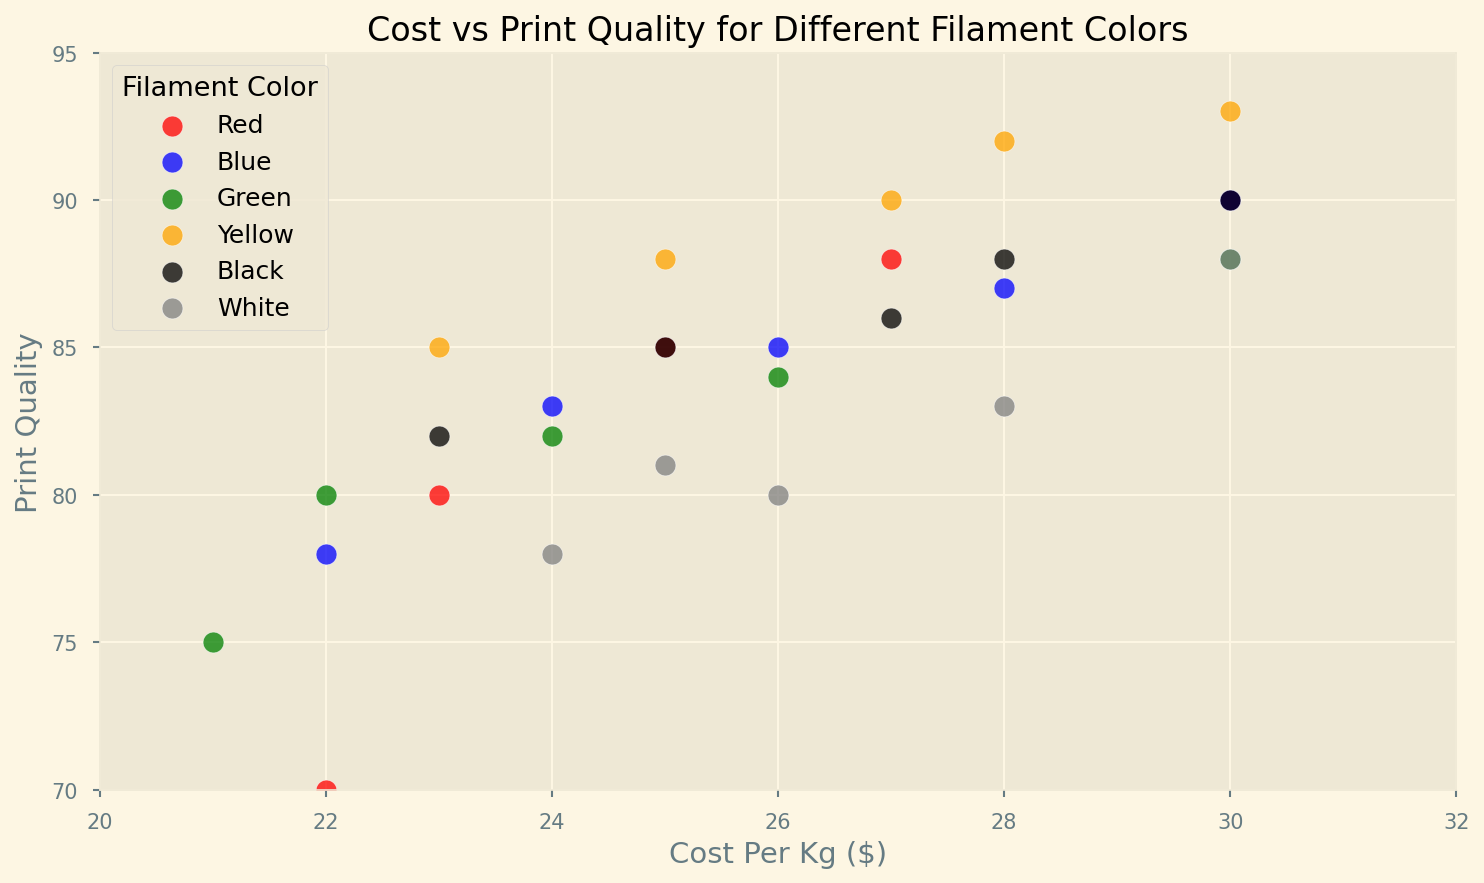What is the cost range for filament in the plot? The plot's x-axis, labeled "Cost Per Kg ($)," ranges from $20 to $32. This is the span of values shown on the horizontal axis.
Answer: $20 to $32 Which filament color has the highest print quality? The point at the top of the plot represents the highest print quality score. The highest value, 93, is associated with the "Yellow" filament color.
Answer: Yellow What is the average print quality for red filament? Calculate the average print quality for red filament by summing the quality values of red points (85 + 80 + 88 + 90 + 70) and dividing by the number of points (5). The sum is 413 and 413/5 = 82.6.
Answer: 82.6 Which color has the most consistent print quality, based on the spread of data points? Consistency is indicated by how tightly clustered the data points are vertically. The yellow filament points are spread between 85 and 93, and are closely packed on the print quality axis.
Answer: Yellow Which filament color has the lowest minimum print quality? The lowest print quality point on the plot is 70, associated with the "Red" filament.
Answer: Red Do any filament colors show a clear correlation between cost and print quality? Check the trend of data points based on each color. For example, yellow and black show an upward trend, suggesting that as the cost increases, print quality also increases.
Answer: Yellow and Black What is the range of print quality values for white filament? Identify the highest and lowest print quality scores for white filament on the plot. The range is from 78 to 88.
Answer: 78 to 88 Which filament color(s) exceed a print quality score of 90? Points with print quality above 90 need to be identified on the plot. Only yellow filament has points above 90, specifically scoring 92 and 93.
Answer: Yellow What is the difference in print quality between the highest-scoring yellow filament and the lowest-scoring green filament? Subtract the lowest green print quality (75) from the highest yellow print quality (93). 93 - 75 = 18.
Answer: 18 Among blue and white filaments, which has better overall print quality? Compare the spread and average position of blue and white data points vertically on the plot. Blue filament points tend to be higher on average, indicating better overall print quality.
Answer: Blue 